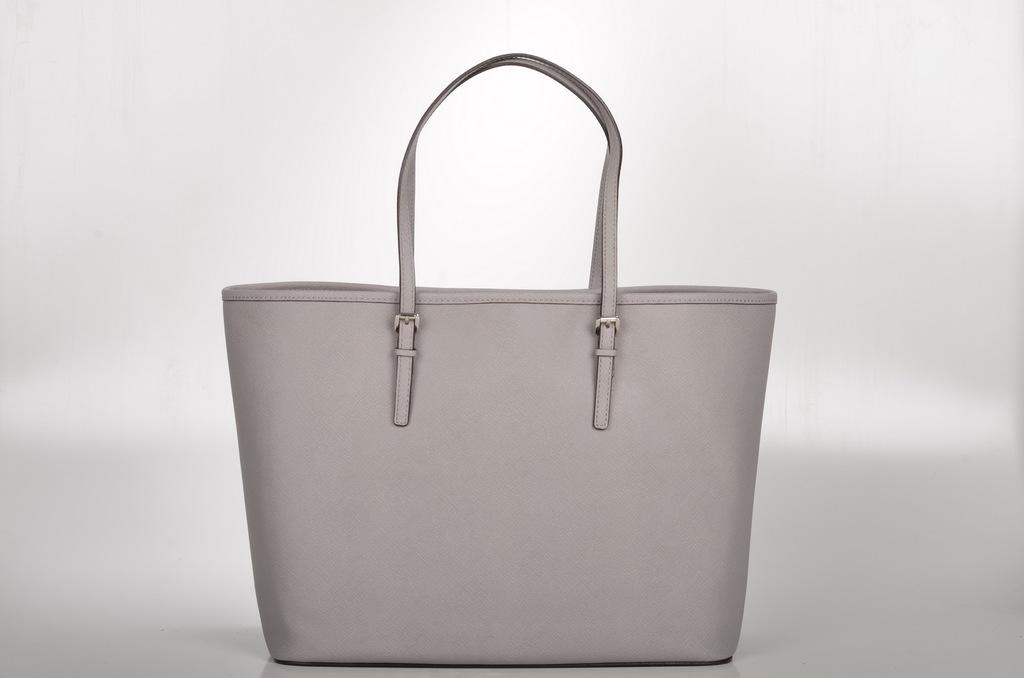What type of accessory is visible in the image? There is a handbag in the image. What type of cord is attached to the handbag in the image? There is no cord attached to the handbag in the image. What type of war is depicted in the image? There is no war depicted in the image; it only features a handbag. 